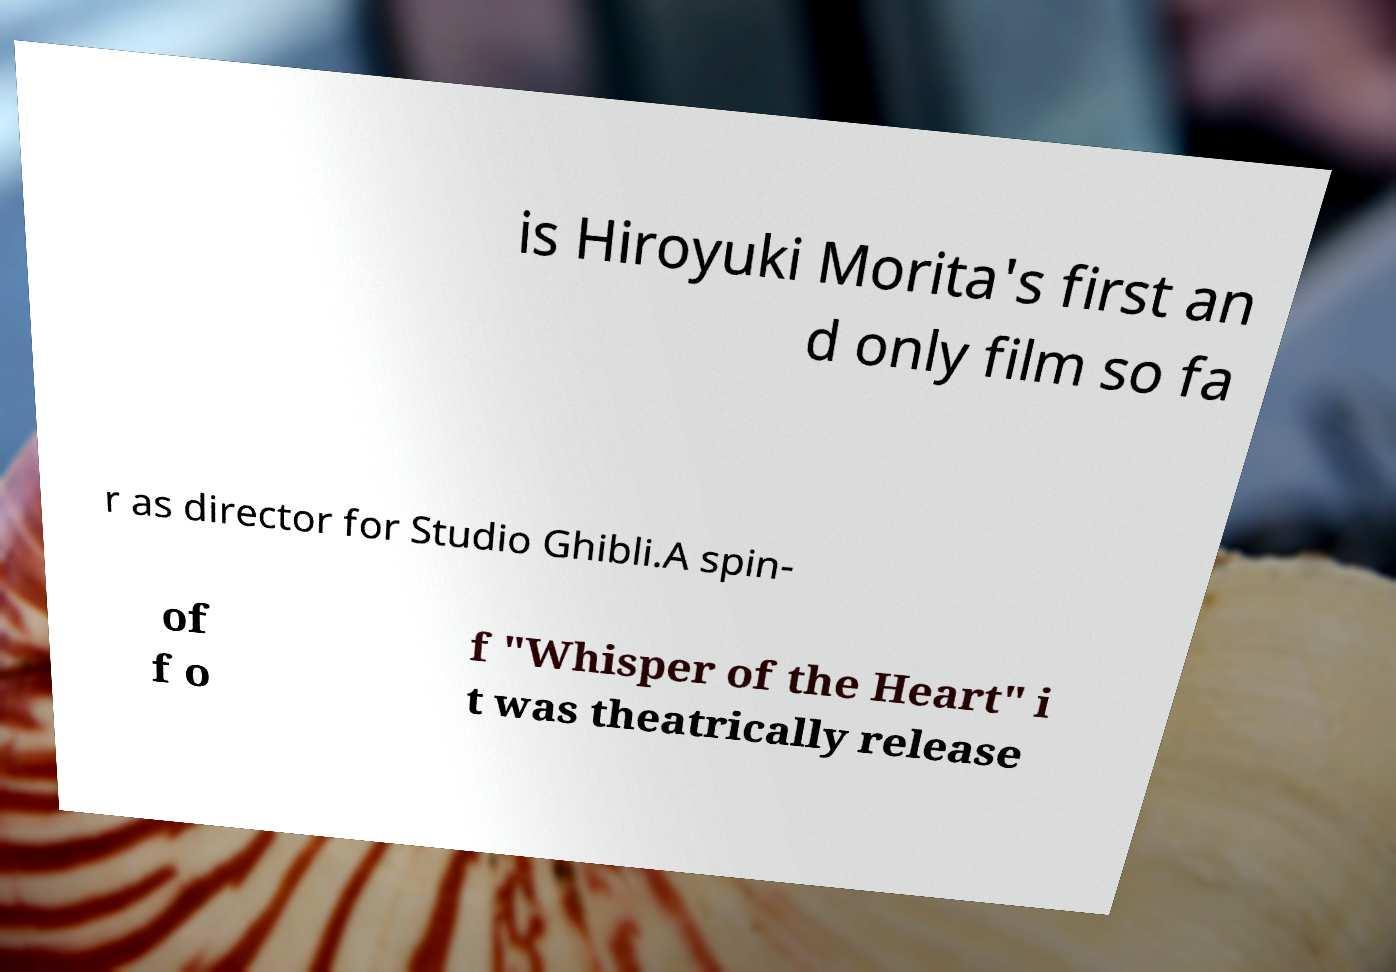For documentation purposes, I need the text within this image transcribed. Could you provide that? is Hiroyuki Morita's first an d only film so fa r as director for Studio Ghibli.A spin- of f o f "Whisper of the Heart" i t was theatrically release 